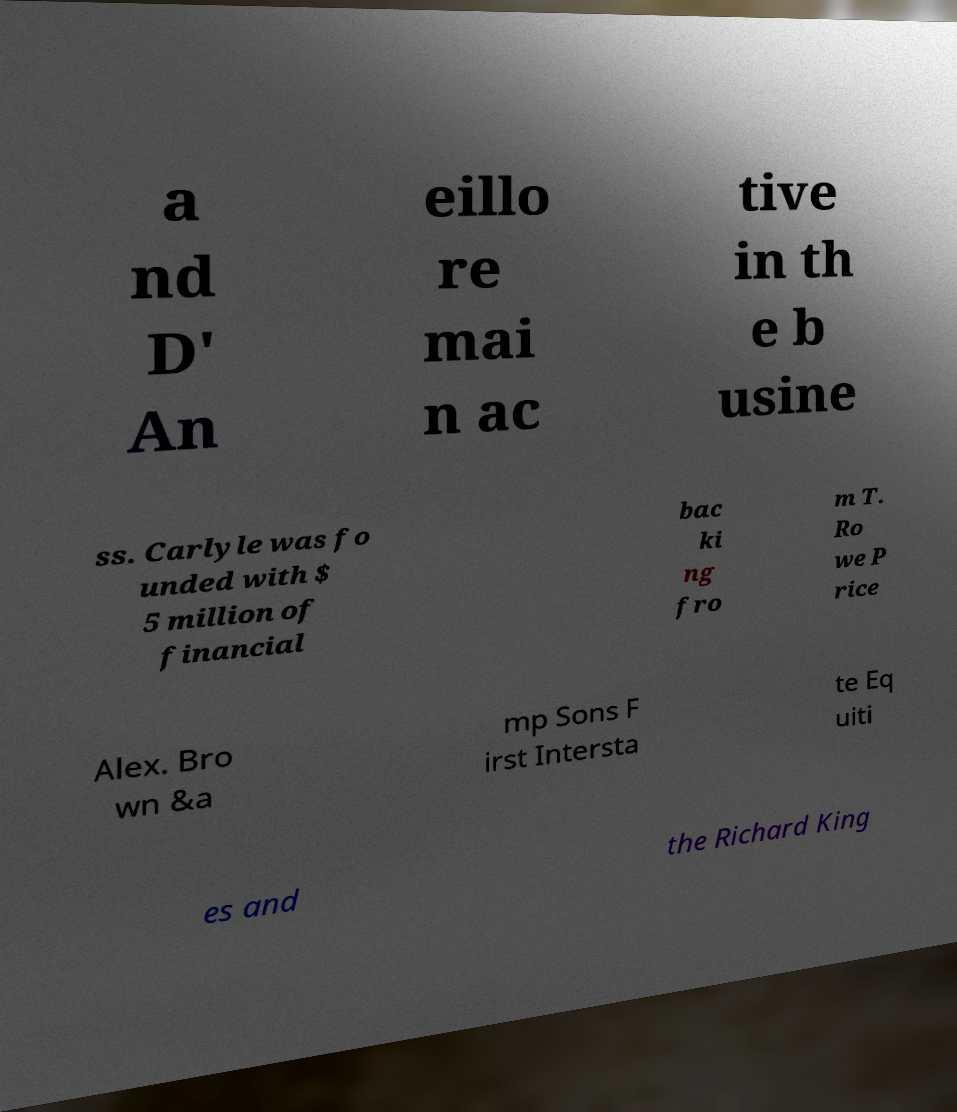What messages or text are displayed in this image? I need them in a readable, typed format. a nd D' An eillo re mai n ac tive in th e b usine ss. Carlyle was fo unded with $ 5 million of financial bac ki ng fro m T. Ro we P rice Alex. Bro wn &a mp Sons F irst Intersta te Eq uiti es and the Richard King 